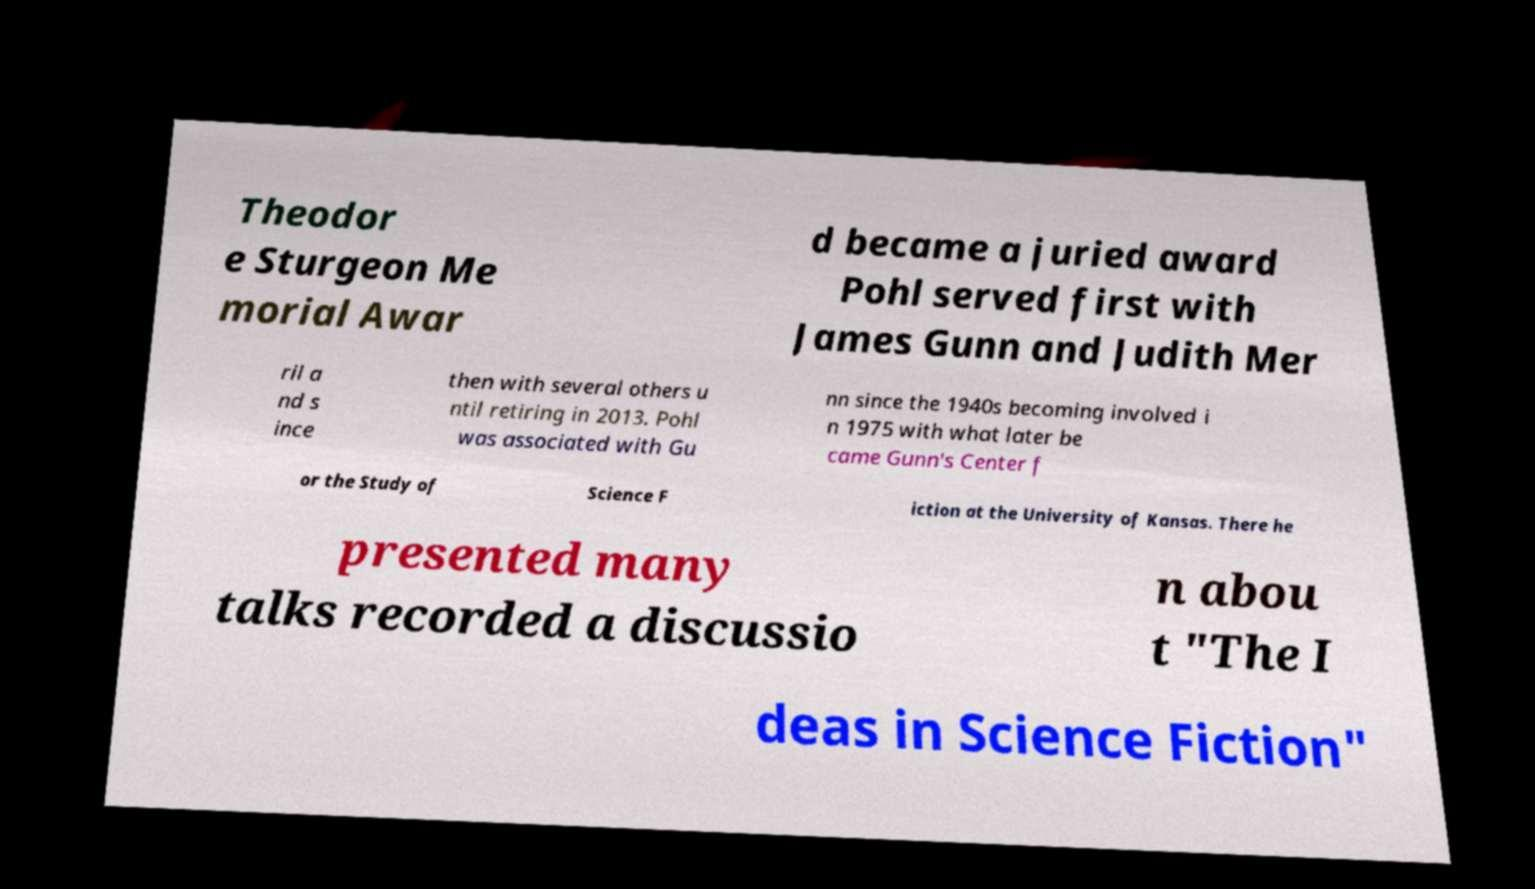Could you assist in decoding the text presented in this image and type it out clearly? Theodor e Sturgeon Me morial Awar d became a juried award Pohl served first with James Gunn and Judith Mer ril a nd s ince then with several others u ntil retiring in 2013. Pohl was associated with Gu nn since the 1940s becoming involved i n 1975 with what later be came Gunn's Center f or the Study of Science F iction at the University of Kansas. There he presented many talks recorded a discussio n abou t "The I deas in Science Fiction" 